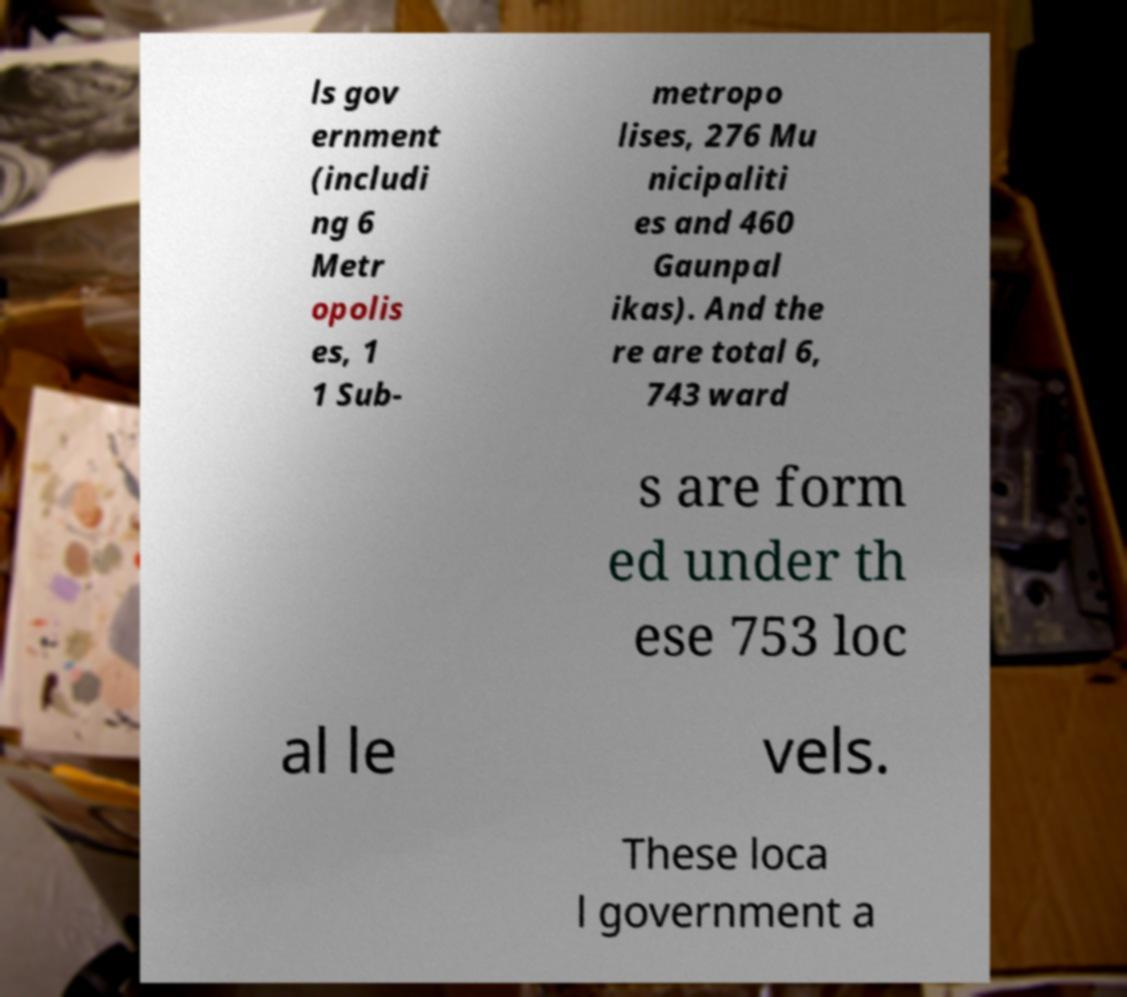Could you extract and type out the text from this image? ls gov ernment (includi ng 6 Metr opolis es, 1 1 Sub- metropo lises, 276 Mu nicipaliti es and 460 Gaunpal ikas). And the re are total 6, 743 ward s are form ed under th ese 753 loc al le vels. These loca l government a 